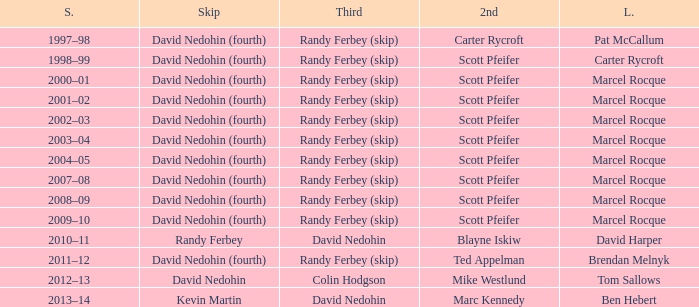Which Second has a Lead of ben hebert? Marc Kennedy. 